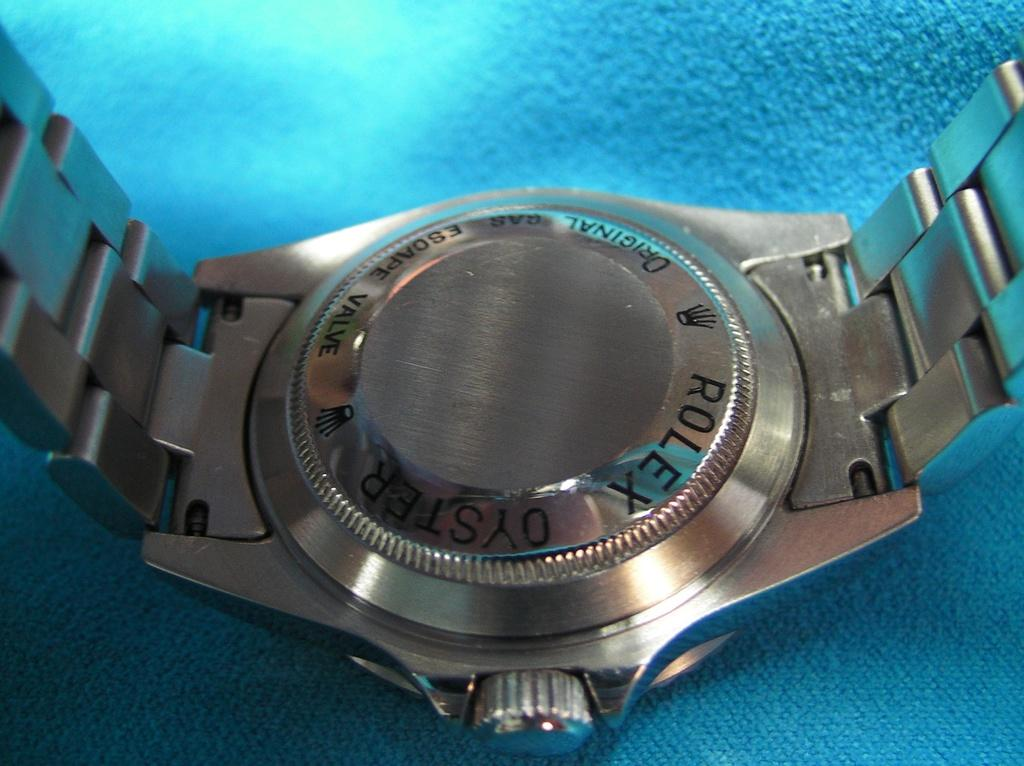<image>
Create a compact narrative representing the image presented. A Rolex Oyster watch is sitting on a blue surface. 